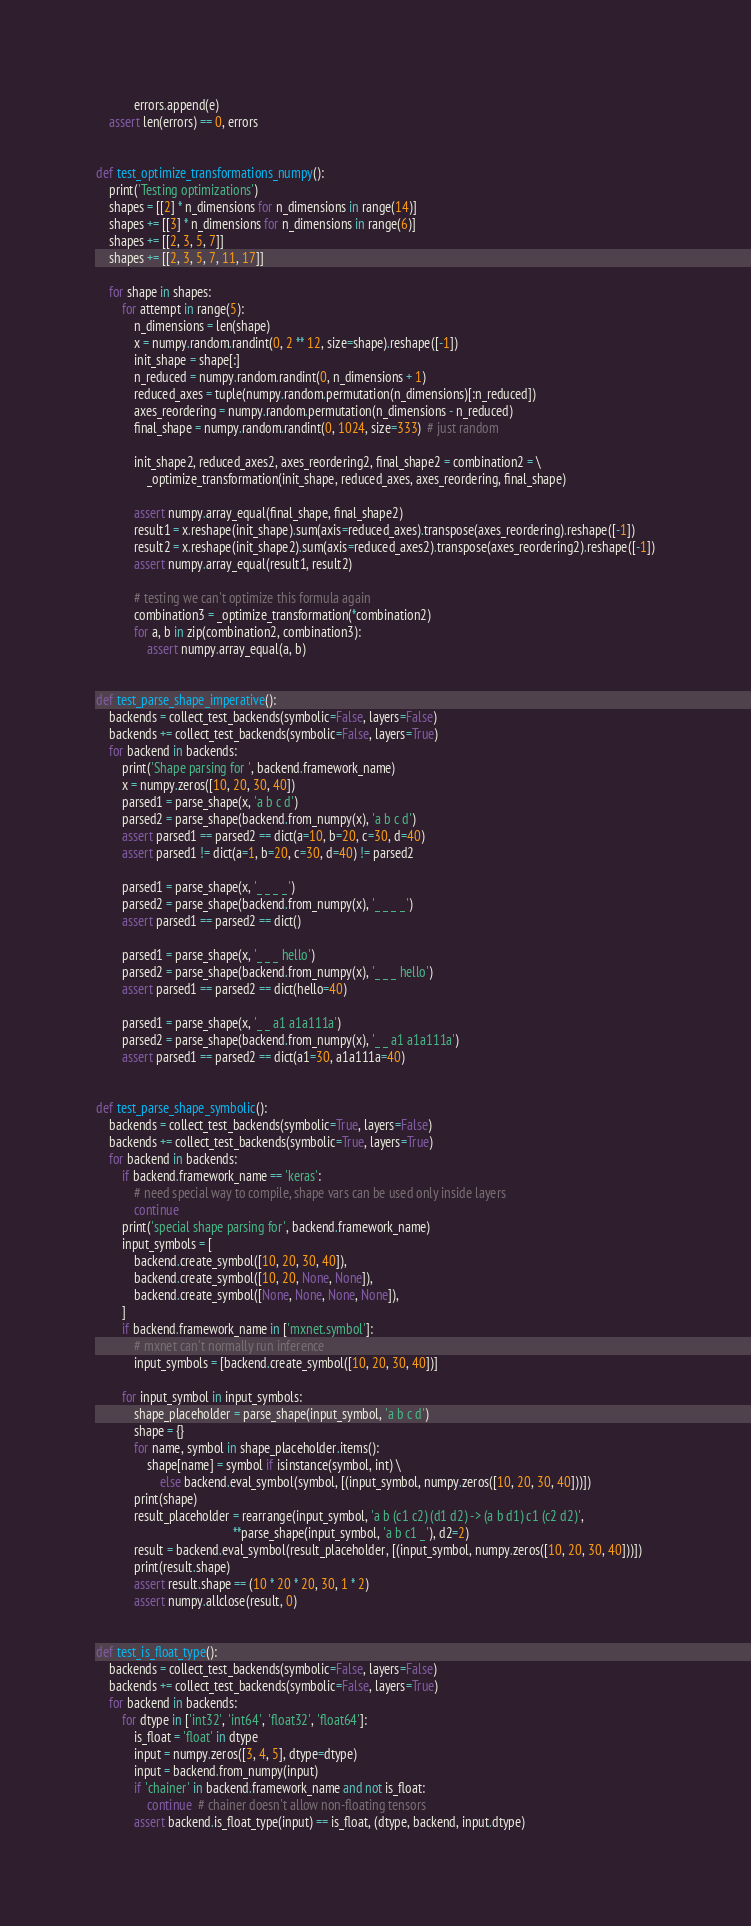<code> <loc_0><loc_0><loc_500><loc_500><_Python_>            errors.append(e)
    assert len(errors) == 0, errors


def test_optimize_transformations_numpy():
    print('Testing optimizations')
    shapes = [[2] * n_dimensions for n_dimensions in range(14)]
    shapes += [[3] * n_dimensions for n_dimensions in range(6)]
    shapes += [[2, 3, 5, 7]]
    shapes += [[2, 3, 5, 7, 11, 17]]

    for shape in shapes:
        for attempt in range(5):
            n_dimensions = len(shape)
            x = numpy.random.randint(0, 2 ** 12, size=shape).reshape([-1])
            init_shape = shape[:]
            n_reduced = numpy.random.randint(0, n_dimensions + 1)
            reduced_axes = tuple(numpy.random.permutation(n_dimensions)[:n_reduced])
            axes_reordering = numpy.random.permutation(n_dimensions - n_reduced)
            final_shape = numpy.random.randint(0, 1024, size=333)  # just random

            init_shape2, reduced_axes2, axes_reordering2, final_shape2 = combination2 = \
                _optimize_transformation(init_shape, reduced_axes, axes_reordering, final_shape)

            assert numpy.array_equal(final_shape, final_shape2)
            result1 = x.reshape(init_shape).sum(axis=reduced_axes).transpose(axes_reordering).reshape([-1])
            result2 = x.reshape(init_shape2).sum(axis=reduced_axes2).transpose(axes_reordering2).reshape([-1])
            assert numpy.array_equal(result1, result2)

            # testing we can't optimize this formula again
            combination3 = _optimize_transformation(*combination2)
            for a, b in zip(combination2, combination3):
                assert numpy.array_equal(a, b)


def test_parse_shape_imperative():
    backends = collect_test_backends(symbolic=False, layers=False)
    backends += collect_test_backends(symbolic=False, layers=True)
    for backend in backends:
        print('Shape parsing for ', backend.framework_name)
        x = numpy.zeros([10, 20, 30, 40])
        parsed1 = parse_shape(x, 'a b c d')
        parsed2 = parse_shape(backend.from_numpy(x), 'a b c d')
        assert parsed1 == parsed2 == dict(a=10, b=20, c=30, d=40)
        assert parsed1 != dict(a=1, b=20, c=30, d=40) != parsed2

        parsed1 = parse_shape(x, '_ _ _ _')
        parsed2 = parse_shape(backend.from_numpy(x), '_ _ _ _')
        assert parsed1 == parsed2 == dict()

        parsed1 = parse_shape(x, '_ _ _ hello')
        parsed2 = parse_shape(backend.from_numpy(x), '_ _ _ hello')
        assert parsed1 == parsed2 == dict(hello=40)

        parsed1 = parse_shape(x, '_ _ a1 a1a111a')
        parsed2 = parse_shape(backend.from_numpy(x), '_ _ a1 a1a111a')
        assert parsed1 == parsed2 == dict(a1=30, a1a111a=40)


def test_parse_shape_symbolic():
    backends = collect_test_backends(symbolic=True, layers=False)
    backends += collect_test_backends(symbolic=True, layers=True)
    for backend in backends:
        if backend.framework_name == 'keras':
            # need special way to compile, shape vars can be used only inside layers
            continue
        print('special shape parsing for', backend.framework_name)
        input_symbols = [
            backend.create_symbol([10, 20, 30, 40]),
            backend.create_symbol([10, 20, None, None]),
            backend.create_symbol([None, None, None, None]),
        ]
        if backend.framework_name in ['mxnet.symbol']:
            # mxnet can't normally run inference
            input_symbols = [backend.create_symbol([10, 20, 30, 40])]

        for input_symbol in input_symbols:
            shape_placeholder = parse_shape(input_symbol, 'a b c d')
            shape = {}
            for name, symbol in shape_placeholder.items():
                shape[name] = symbol if isinstance(symbol, int) \
                    else backend.eval_symbol(symbol, [(input_symbol, numpy.zeros([10, 20, 30, 40]))])
            print(shape)
            result_placeholder = rearrange(input_symbol, 'a b (c1 c2) (d1 d2) -> (a b d1) c1 (c2 d2)',
                                           **parse_shape(input_symbol, 'a b c1 _'), d2=2)
            result = backend.eval_symbol(result_placeholder, [(input_symbol, numpy.zeros([10, 20, 30, 40]))])
            print(result.shape)
            assert result.shape == (10 * 20 * 20, 30, 1 * 2)
            assert numpy.allclose(result, 0)


def test_is_float_type():
    backends = collect_test_backends(symbolic=False, layers=False)
    backends += collect_test_backends(symbolic=False, layers=True)
    for backend in backends:
        for dtype in ['int32', 'int64', 'float32', 'float64']:
            is_float = 'float' in dtype
            input = numpy.zeros([3, 4, 5], dtype=dtype)
            input = backend.from_numpy(input)
            if 'chainer' in backend.framework_name and not is_float:
                continue  # chainer doesn't allow non-floating tensors
            assert backend.is_float_type(input) == is_float, (dtype, backend, input.dtype)
</code> 